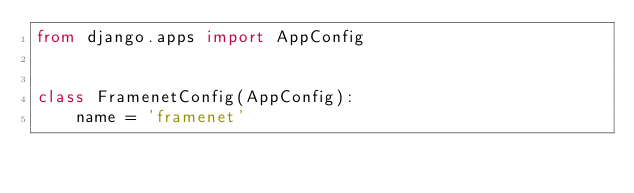<code> <loc_0><loc_0><loc_500><loc_500><_Python_>from django.apps import AppConfig


class FramenetConfig(AppConfig):
    name = 'framenet'
</code> 